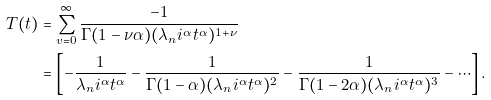<formula> <loc_0><loc_0><loc_500><loc_500>T ( t ) & = \sum _ { v = 0 } ^ { \infty } \frac { - 1 } { \Gamma ( 1 - \nu \alpha ) ( \lambda _ { n } i ^ { \alpha } t ^ { \alpha } ) ^ { 1 + \nu } } \\ & = \left [ - \frac { 1 } { \lambda _ { n } i ^ { \alpha } t ^ { \alpha } } - \frac { 1 } { \Gamma ( 1 - \alpha ) ( \lambda _ { n } i ^ { \alpha } t ^ { \alpha } ) ^ { 2 } } - \frac { 1 } { \Gamma ( 1 - 2 \alpha ) ( \lambda _ { n } i ^ { \alpha } t ^ { \alpha } ) ^ { 3 } } - \cdots \right ] .</formula> 